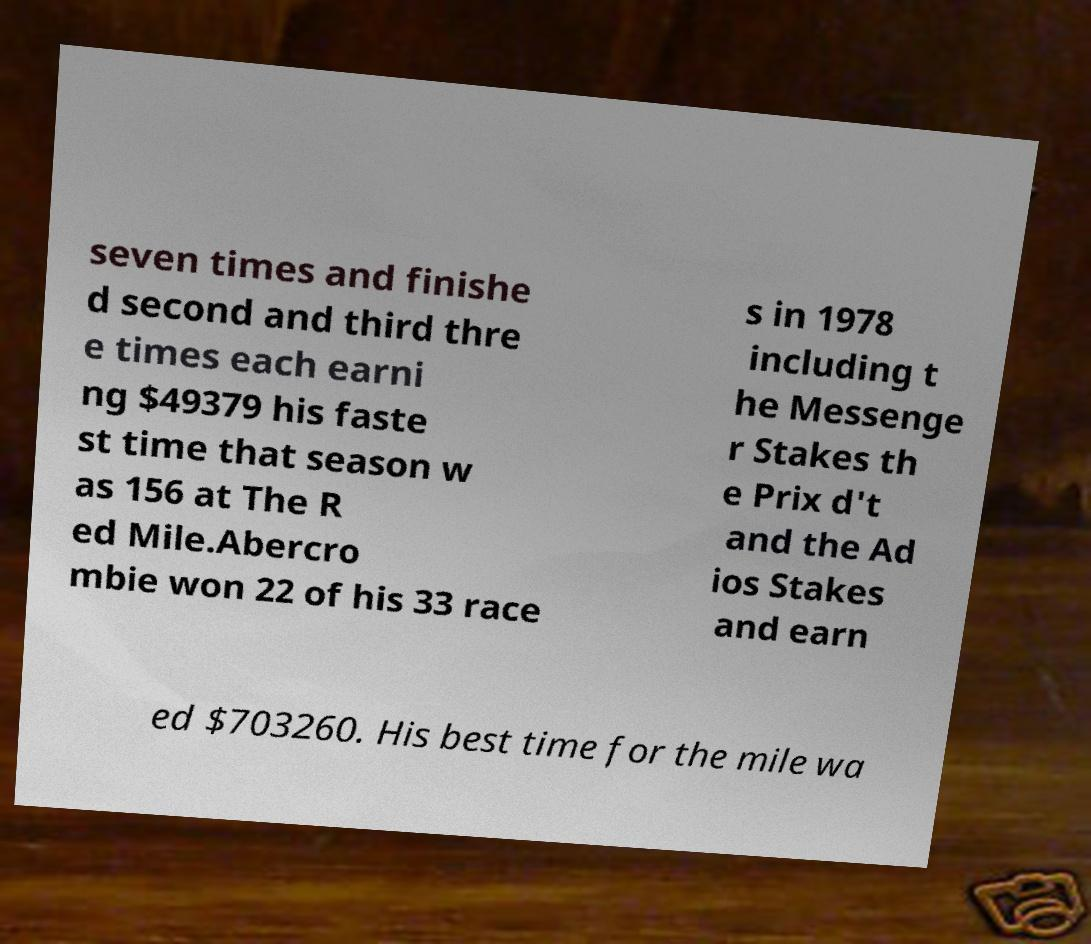What messages or text are displayed in this image? I need them in a readable, typed format. seven times and finishe d second and third thre e times each earni ng $49379 his faste st time that season w as 156 at The R ed Mile.Abercro mbie won 22 of his 33 race s in 1978 including t he Messenge r Stakes th e Prix d't and the Ad ios Stakes and earn ed $703260. His best time for the mile wa 